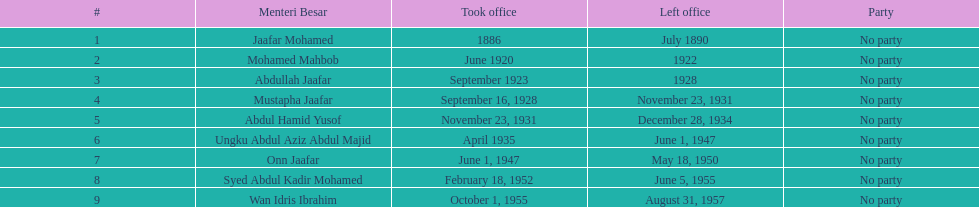How many years did jaafar mohamed serve in office? 4. 